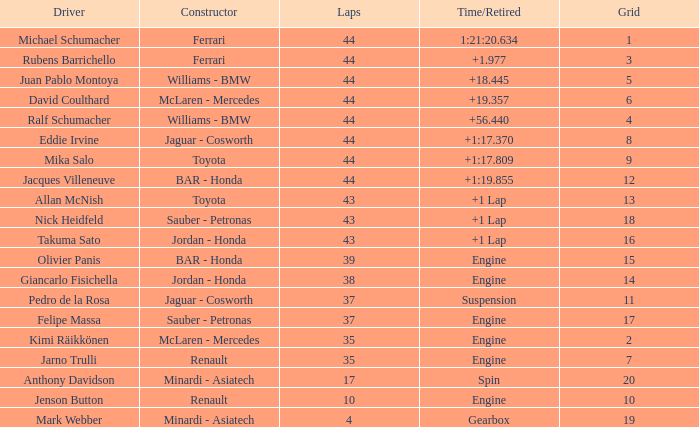Parse the full table. {'header': ['Driver', 'Constructor', 'Laps', 'Time/Retired', 'Grid'], 'rows': [['Michael Schumacher', 'Ferrari', '44', '1:21:20.634', '1'], ['Rubens Barrichello', 'Ferrari', '44', '+1.977', '3'], ['Juan Pablo Montoya', 'Williams - BMW', '44', '+18.445', '5'], ['David Coulthard', 'McLaren - Mercedes', '44', '+19.357', '6'], ['Ralf Schumacher', 'Williams - BMW', '44', '+56.440', '4'], ['Eddie Irvine', 'Jaguar - Cosworth', '44', '+1:17.370', '8'], ['Mika Salo', 'Toyota', '44', '+1:17.809', '9'], ['Jacques Villeneuve', 'BAR - Honda', '44', '+1:19.855', '12'], ['Allan McNish', 'Toyota', '43', '+1 Lap', '13'], ['Nick Heidfeld', 'Sauber - Petronas', '43', '+1 Lap', '18'], ['Takuma Sato', 'Jordan - Honda', '43', '+1 Lap', '16'], ['Olivier Panis', 'BAR - Honda', '39', 'Engine', '15'], ['Giancarlo Fisichella', 'Jordan - Honda', '38', 'Engine', '14'], ['Pedro de la Rosa', 'Jaguar - Cosworth', '37', 'Suspension', '11'], ['Felipe Massa', 'Sauber - Petronas', '37', 'Engine', '17'], ['Kimi Räikkönen', 'McLaren - Mercedes', '35', 'Engine', '2'], ['Jarno Trulli', 'Renault', '35', 'Engine', '7'], ['Anthony Davidson', 'Minardi - Asiatech', '17', 'Spin', '20'], ['Jenson Button', 'Renault', '10', 'Engine', '10'], ['Mark Webber', 'Minardi - Asiatech', '4', 'Gearbox', '19']]} What was the fewest laps for somone who finished +18.445? 44.0. 